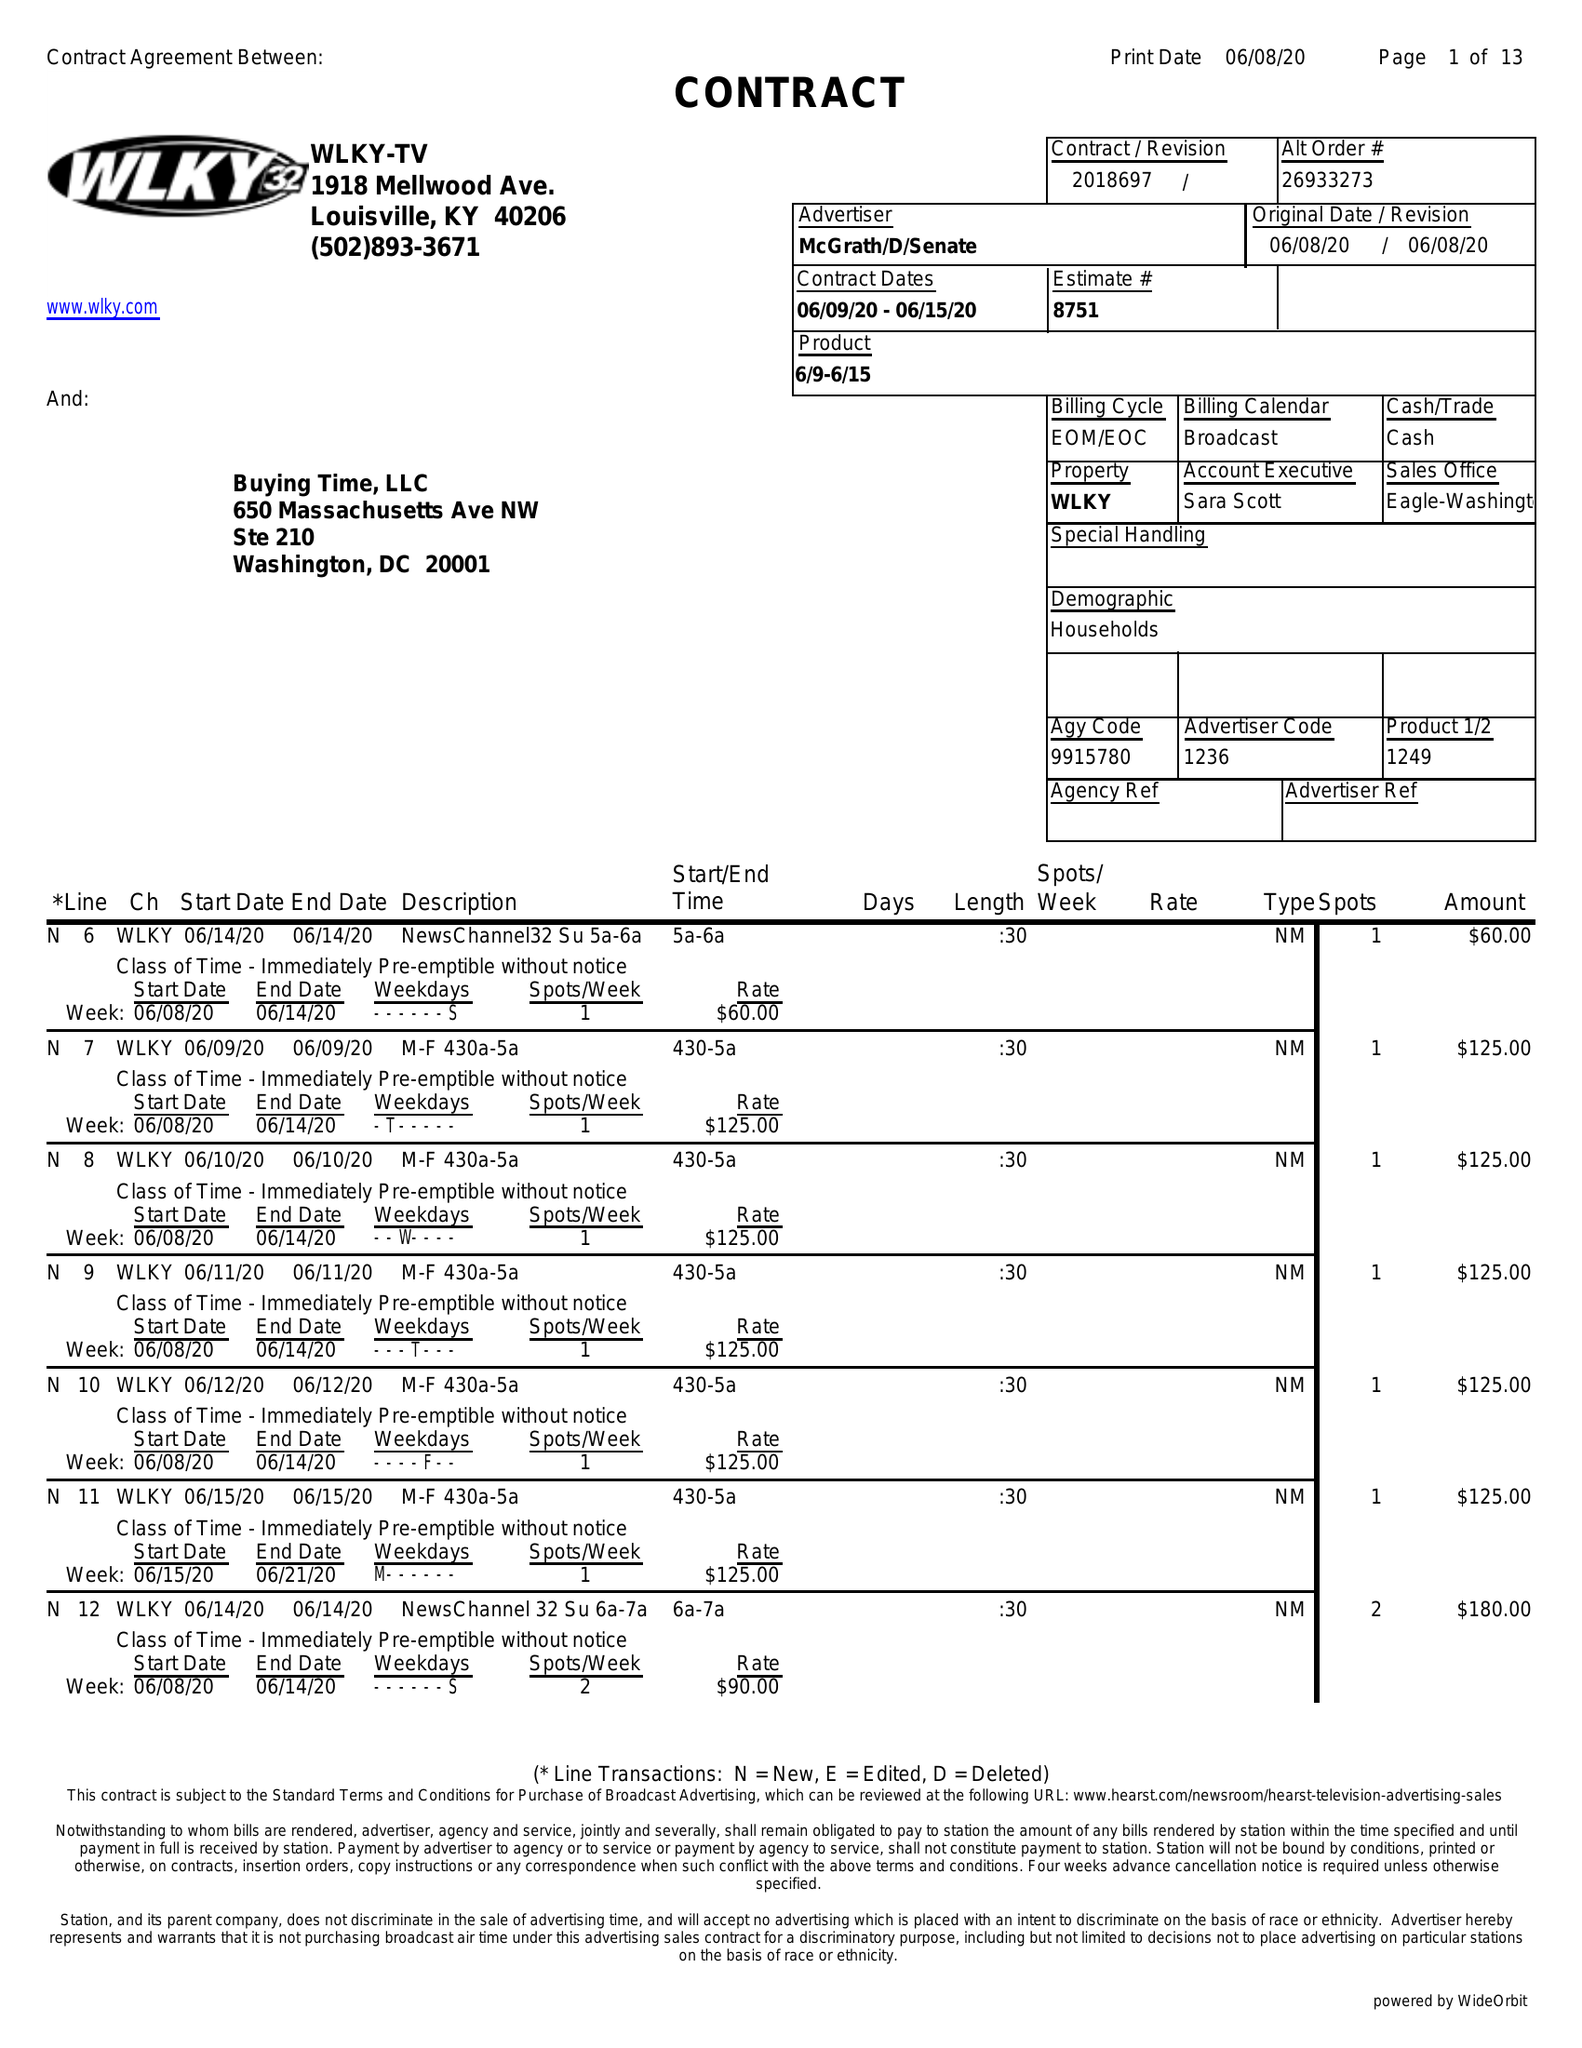What is the value for the contract_num?
Answer the question using a single word or phrase. 2018697 